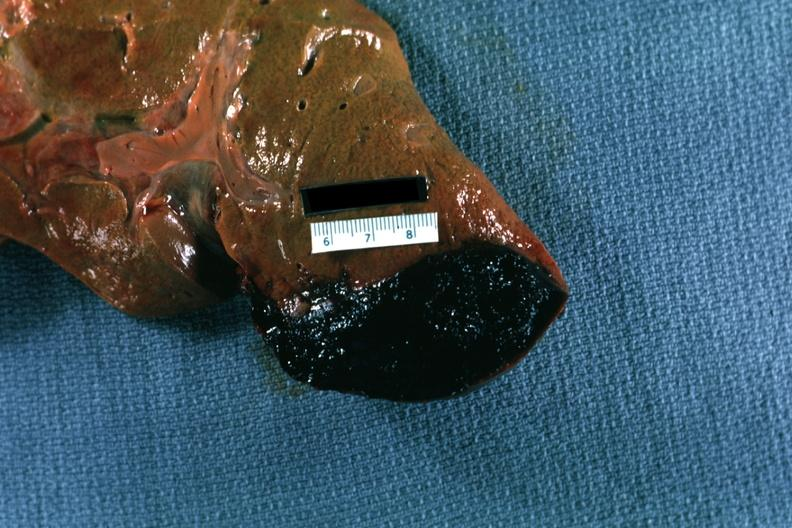what does this image show?
Answer the question using a single word or phrase. Inferior right side cause 